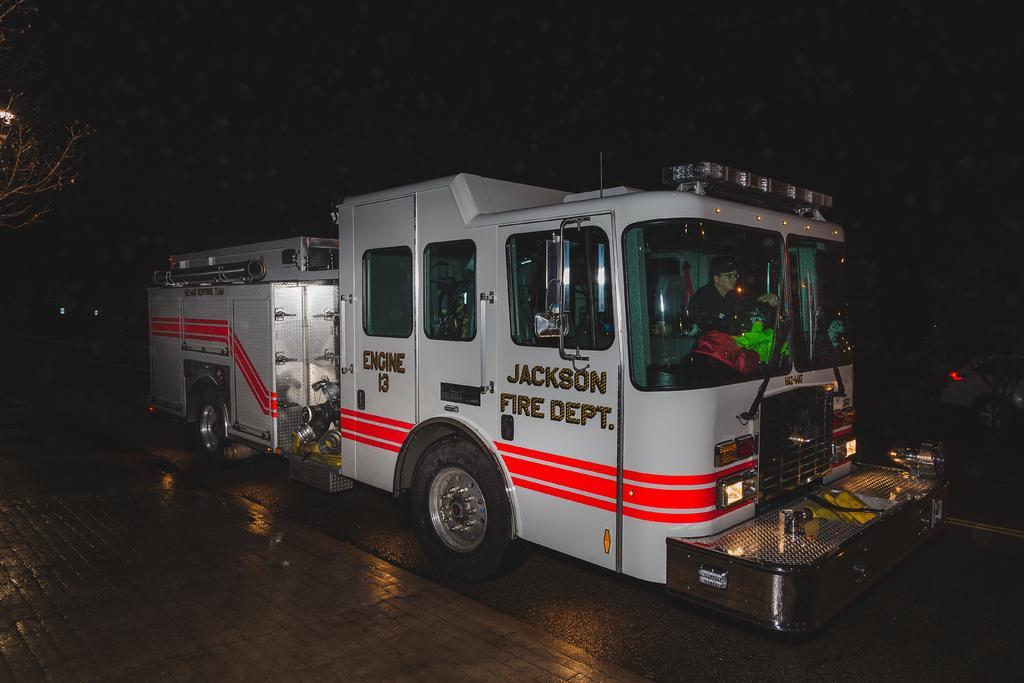Could you give a brief overview of what you see in this image? In this picture, we see a man riding the white vehicle. On the vehicle it is written as "JACKSON FIRE DEPT". In the background, it is black in color and this picture is clicked in the dark. 